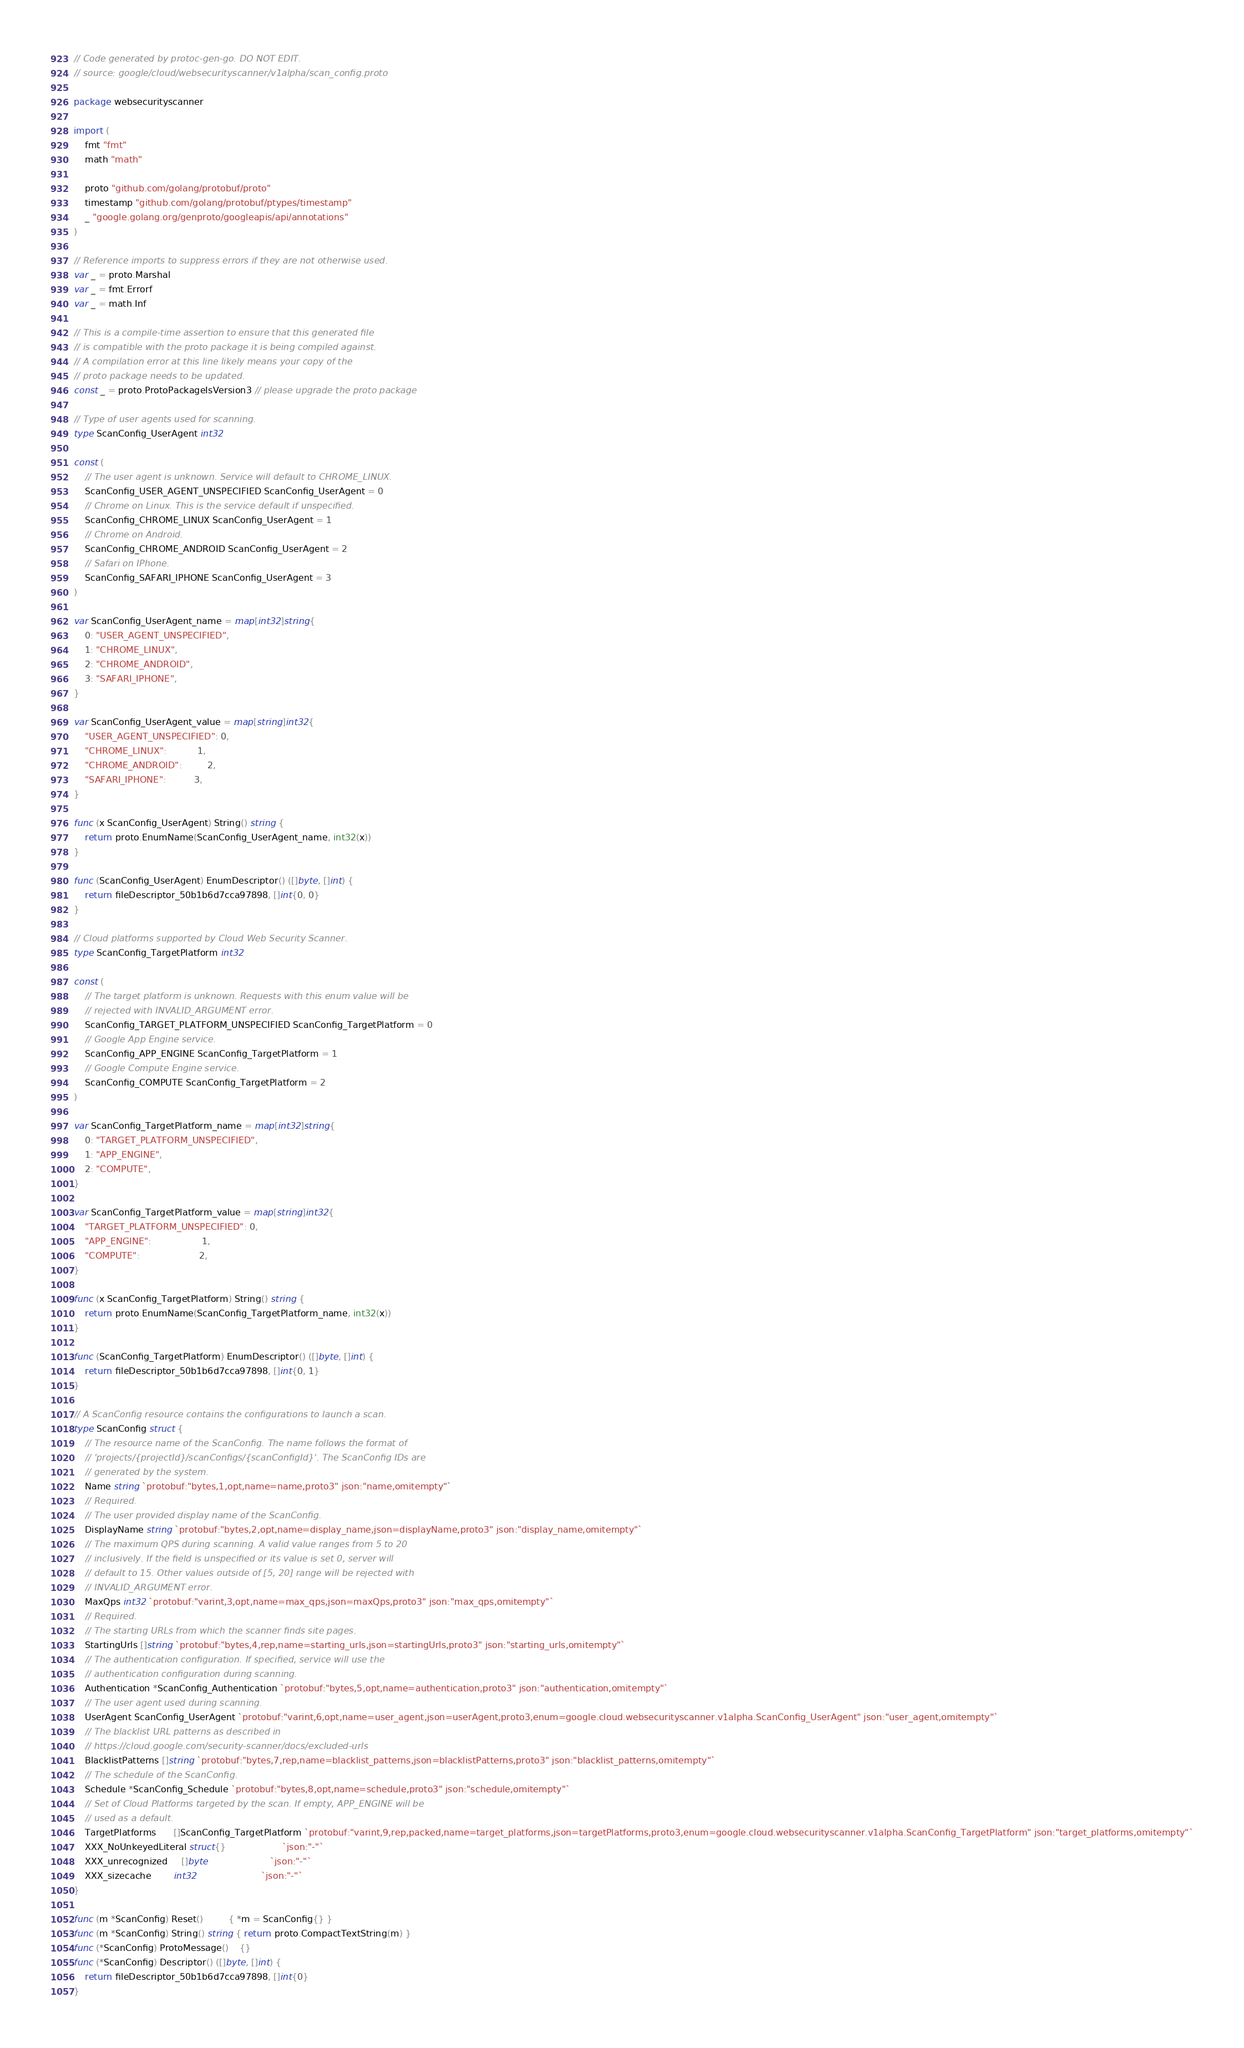Convert code to text. <code><loc_0><loc_0><loc_500><loc_500><_Go_>// Code generated by protoc-gen-go. DO NOT EDIT.
// source: google/cloud/websecurityscanner/v1alpha/scan_config.proto

package websecurityscanner

import (
	fmt "fmt"
	math "math"

	proto "github.com/golang/protobuf/proto"
	timestamp "github.com/golang/protobuf/ptypes/timestamp"
	_ "google.golang.org/genproto/googleapis/api/annotations"
)

// Reference imports to suppress errors if they are not otherwise used.
var _ = proto.Marshal
var _ = fmt.Errorf
var _ = math.Inf

// This is a compile-time assertion to ensure that this generated file
// is compatible with the proto package it is being compiled against.
// A compilation error at this line likely means your copy of the
// proto package needs to be updated.
const _ = proto.ProtoPackageIsVersion3 // please upgrade the proto package

// Type of user agents used for scanning.
type ScanConfig_UserAgent int32

const (
	// The user agent is unknown. Service will default to CHROME_LINUX.
	ScanConfig_USER_AGENT_UNSPECIFIED ScanConfig_UserAgent = 0
	// Chrome on Linux. This is the service default if unspecified.
	ScanConfig_CHROME_LINUX ScanConfig_UserAgent = 1
	// Chrome on Android.
	ScanConfig_CHROME_ANDROID ScanConfig_UserAgent = 2
	// Safari on IPhone.
	ScanConfig_SAFARI_IPHONE ScanConfig_UserAgent = 3
)

var ScanConfig_UserAgent_name = map[int32]string{
	0: "USER_AGENT_UNSPECIFIED",
	1: "CHROME_LINUX",
	2: "CHROME_ANDROID",
	3: "SAFARI_IPHONE",
}

var ScanConfig_UserAgent_value = map[string]int32{
	"USER_AGENT_UNSPECIFIED": 0,
	"CHROME_LINUX":           1,
	"CHROME_ANDROID":         2,
	"SAFARI_IPHONE":          3,
}

func (x ScanConfig_UserAgent) String() string {
	return proto.EnumName(ScanConfig_UserAgent_name, int32(x))
}

func (ScanConfig_UserAgent) EnumDescriptor() ([]byte, []int) {
	return fileDescriptor_50b1b6d7cca97898, []int{0, 0}
}

// Cloud platforms supported by Cloud Web Security Scanner.
type ScanConfig_TargetPlatform int32

const (
	// The target platform is unknown. Requests with this enum value will be
	// rejected with INVALID_ARGUMENT error.
	ScanConfig_TARGET_PLATFORM_UNSPECIFIED ScanConfig_TargetPlatform = 0
	// Google App Engine service.
	ScanConfig_APP_ENGINE ScanConfig_TargetPlatform = 1
	// Google Compute Engine service.
	ScanConfig_COMPUTE ScanConfig_TargetPlatform = 2
)

var ScanConfig_TargetPlatform_name = map[int32]string{
	0: "TARGET_PLATFORM_UNSPECIFIED",
	1: "APP_ENGINE",
	2: "COMPUTE",
}

var ScanConfig_TargetPlatform_value = map[string]int32{
	"TARGET_PLATFORM_UNSPECIFIED": 0,
	"APP_ENGINE":                  1,
	"COMPUTE":                     2,
}

func (x ScanConfig_TargetPlatform) String() string {
	return proto.EnumName(ScanConfig_TargetPlatform_name, int32(x))
}

func (ScanConfig_TargetPlatform) EnumDescriptor() ([]byte, []int) {
	return fileDescriptor_50b1b6d7cca97898, []int{0, 1}
}

// A ScanConfig resource contains the configurations to launch a scan.
type ScanConfig struct {
	// The resource name of the ScanConfig. The name follows the format of
	// 'projects/{projectId}/scanConfigs/{scanConfigId}'. The ScanConfig IDs are
	// generated by the system.
	Name string `protobuf:"bytes,1,opt,name=name,proto3" json:"name,omitempty"`
	// Required.
	// The user provided display name of the ScanConfig.
	DisplayName string `protobuf:"bytes,2,opt,name=display_name,json=displayName,proto3" json:"display_name,omitempty"`
	// The maximum QPS during scanning. A valid value ranges from 5 to 20
	// inclusively. If the field is unspecified or its value is set 0, server will
	// default to 15. Other values outside of [5, 20] range will be rejected with
	// INVALID_ARGUMENT error.
	MaxQps int32 `protobuf:"varint,3,opt,name=max_qps,json=maxQps,proto3" json:"max_qps,omitempty"`
	// Required.
	// The starting URLs from which the scanner finds site pages.
	StartingUrls []string `protobuf:"bytes,4,rep,name=starting_urls,json=startingUrls,proto3" json:"starting_urls,omitempty"`
	// The authentication configuration. If specified, service will use the
	// authentication configuration during scanning.
	Authentication *ScanConfig_Authentication `protobuf:"bytes,5,opt,name=authentication,proto3" json:"authentication,omitempty"`
	// The user agent used during scanning.
	UserAgent ScanConfig_UserAgent `protobuf:"varint,6,opt,name=user_agent,json=userAgent,proto3,enum=google.cloud.websecurityscanner.v1alpha.ScanConfig_UserAgent" json:"user_agent,omitempty"`
	// The blacklist URL patterns as described in
	// https://cloud.google.com/security-scanner/docs/excluded-urls
	BlacklistPatterns []string `protobuf:"bytes,7,rep,name=blacklist_patterns,json=blacklistPatterns,proto3" json:"blacklist_patterns,omitempty"`
	// The schedule of the ScanConfig.
	Schedule *ScanConfig_Schedule `protobuf:"bytes,8,opt,name=schedule,proto3" json:"schedule,omitempty"`
	// Set of Cloud Platforms targeted by the scan. If empty, APP_ENGINE will be
	// used as a default.
	TargetPlatforms      []ScanConfig_TargetPlatform `protobuf:"varint,9,rep,packed,name=target_platforms,json=targetPlatforms,proto3,enum=google.cloud.websecurityscanner.v1alpha.ScanConfig_TargetPlatform" json:"target_platforms,omitempty"`
	XXX_NoUnkeyedLiteral struct{}                    `json:"-"`
	XXX_unrecognized     []byte                      `json:"-"`
	XXX_sizecache        int32                       `json:"-"`
}

func (m *ScanConfig) Reset()         { *m = ScanConfig{} }
func (m *ScanConfig) String() string { return proto.CompactTextString(m) }
func (*ScanConfig) ProtoMessage()    {}
func (*ScanConfig) Descriptor() ([]byte, []int) {
	return fileDescriptor_50b1b6d7cca97898, []int{0}
}
</code> 